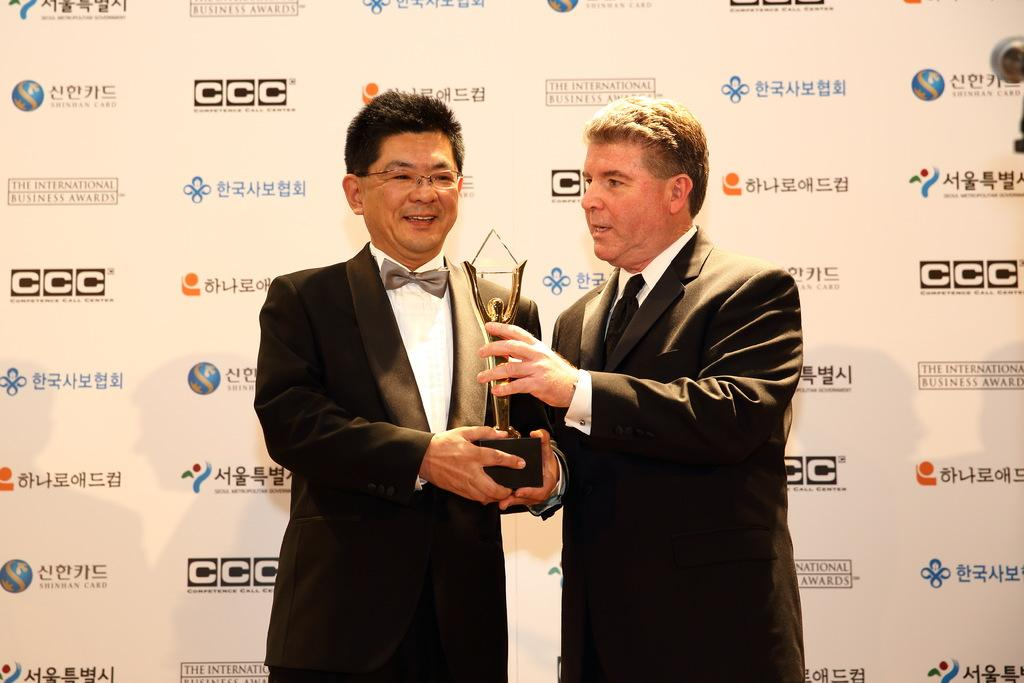How many people are in the image? There are two men in the image. Where are the men located in the image? The men are standing in the center of the image. What are the men holding in the image? The men are holding a trophy. What can be seen in the background of the image? There is a board visible in the background of the image. How much sugar is in the trophy held by the men in the image? There is no sugar present in the trophy held by the men in the image. What type of stick can be seen leaning against the board in the background? There is no stick visible in the image, only a board in the background. 